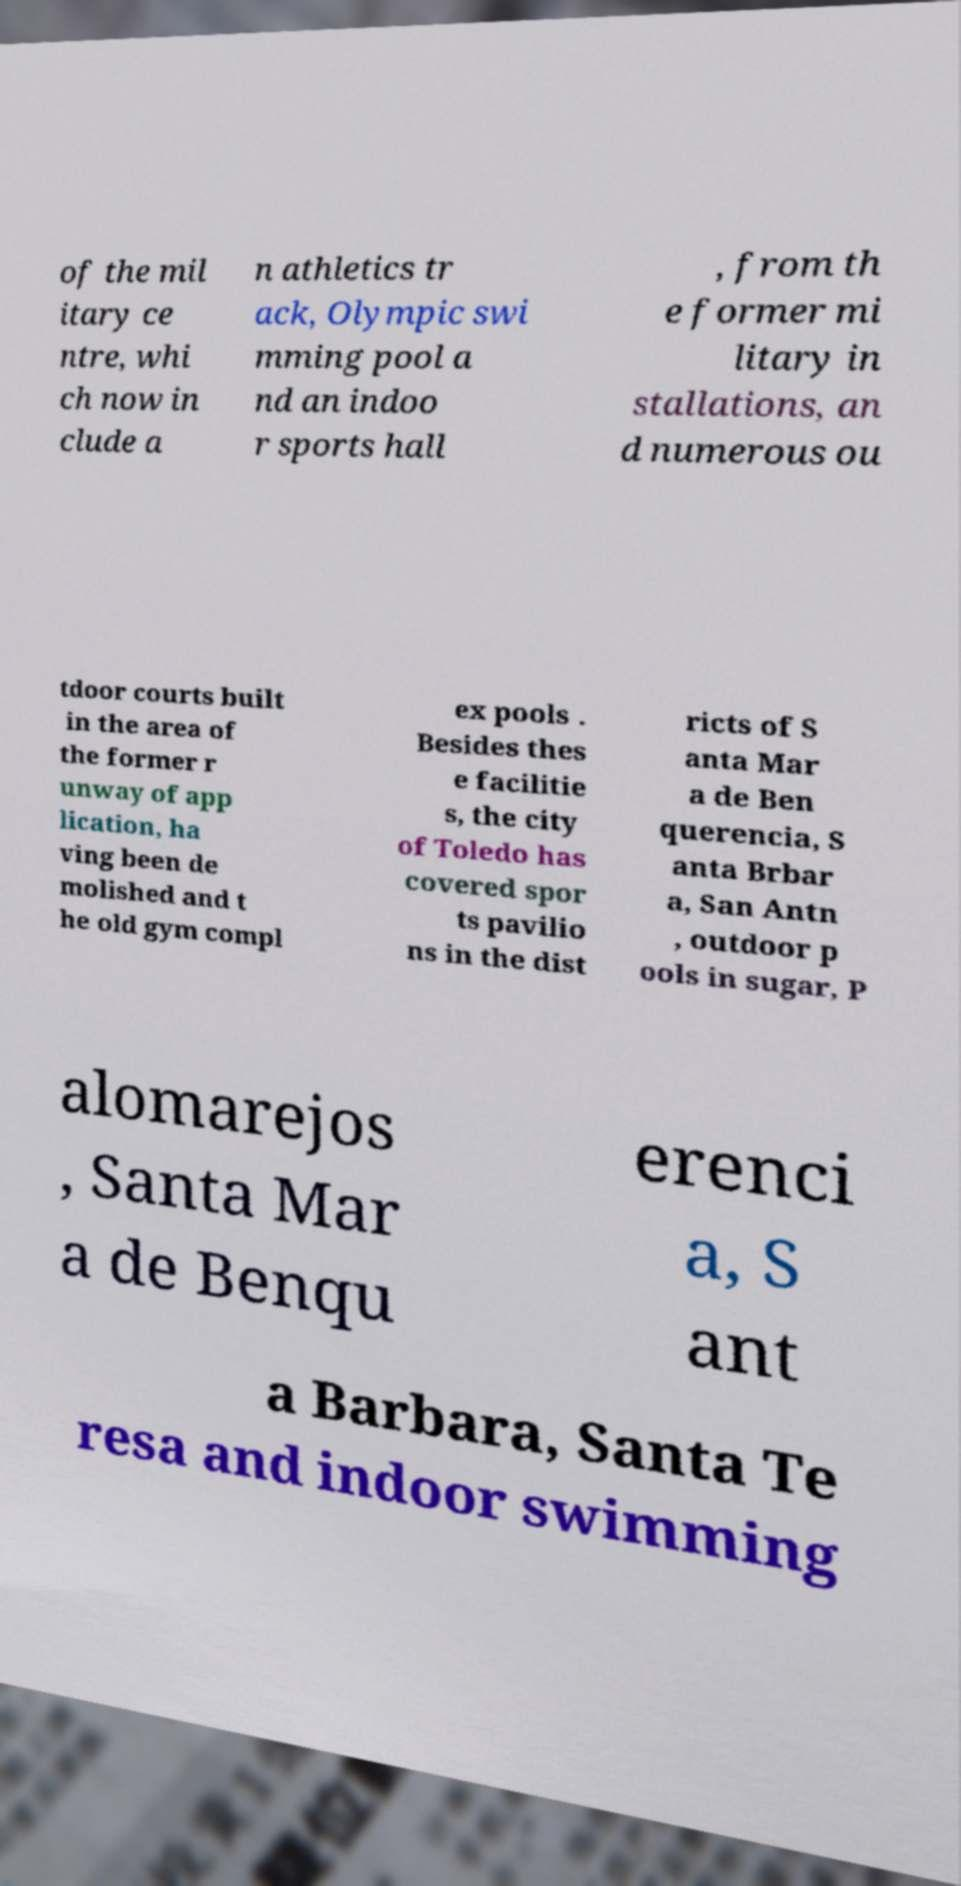For documentation purposes, I need the text within this image transcribed. Could you provide that? of the mil itary ce ntre, whi ch now in clude a n athletics tr ack, Olympic swi mming pool a nd an indoo r sports hall , from th e former mi litary in stallations, an d numerous ou tdoor courts built in the area of the former r unway of app lication, ha ving been de molished and t he old gym compl ex pools . Besides thes e facilitie s, the city of Toledo has covered spor ts pavilio ns in the dist ricts of S anta Mar a de Ben querencia, S anta Brbar a, San Antn , outdoor p ools in sugar, P alomarejos , Santa Mar a de Benqu erenci a, S ant a Barbara, Santa Te resa and indoor swimming 